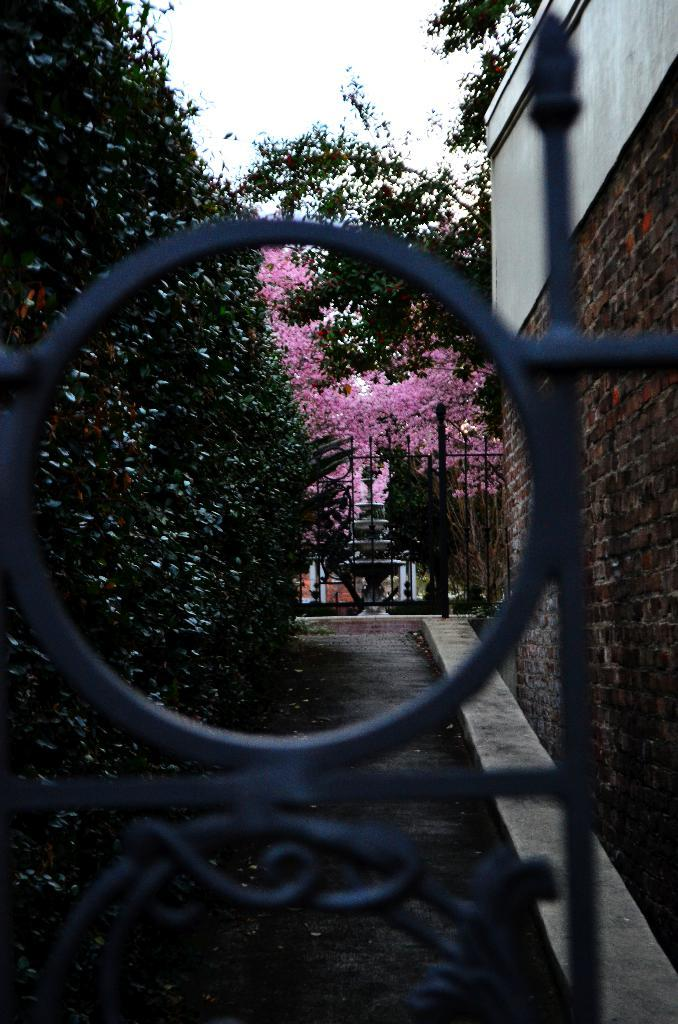What structure is present in the image? There is a gate in the image. What can be seen on the wall in the image? There are plants on the wall in the image. What are the plants doing in the image? The plants have flowers in the image. What material is the wall made of? The wall is made of bricks. What type of mint is growing on the wall in the image? There is no mint growing on the wall in the image; it features plants with flowers. Can you tell me how many friends are visible in the image? There are no friends present in the image; it features a gate, plants with flowers, and a brick wall. 